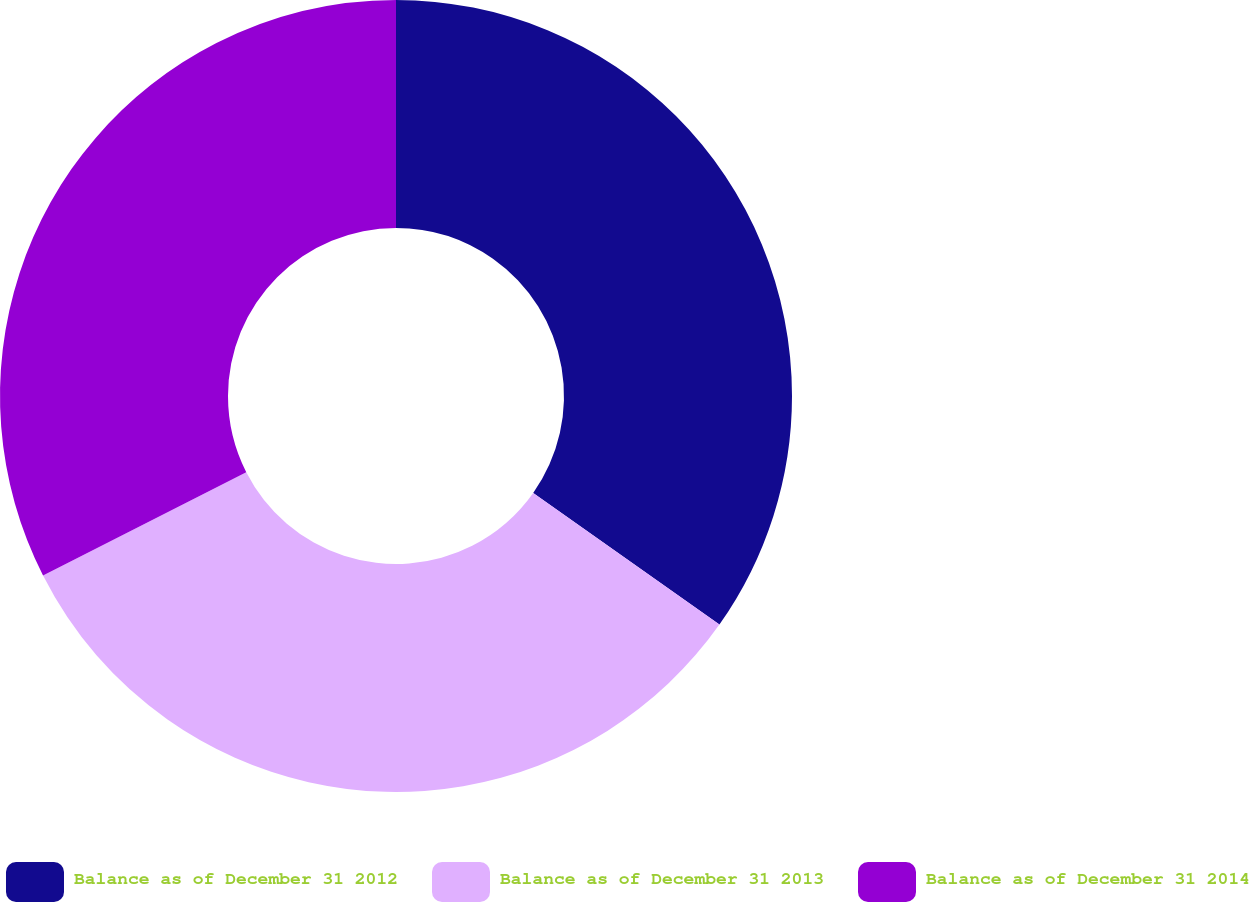Convert chart to OTSL. <chart><loc_0><loc_0><loc_500><loc_500><pie_chart><fcel>Balance as of December 31 2012<fcel>Balance as of December 31 2013<fcel>Balance as of December 31 2014<nl><fcel>34.79%<fcel>32.72%<fcel>32.49%<nl></chart> 